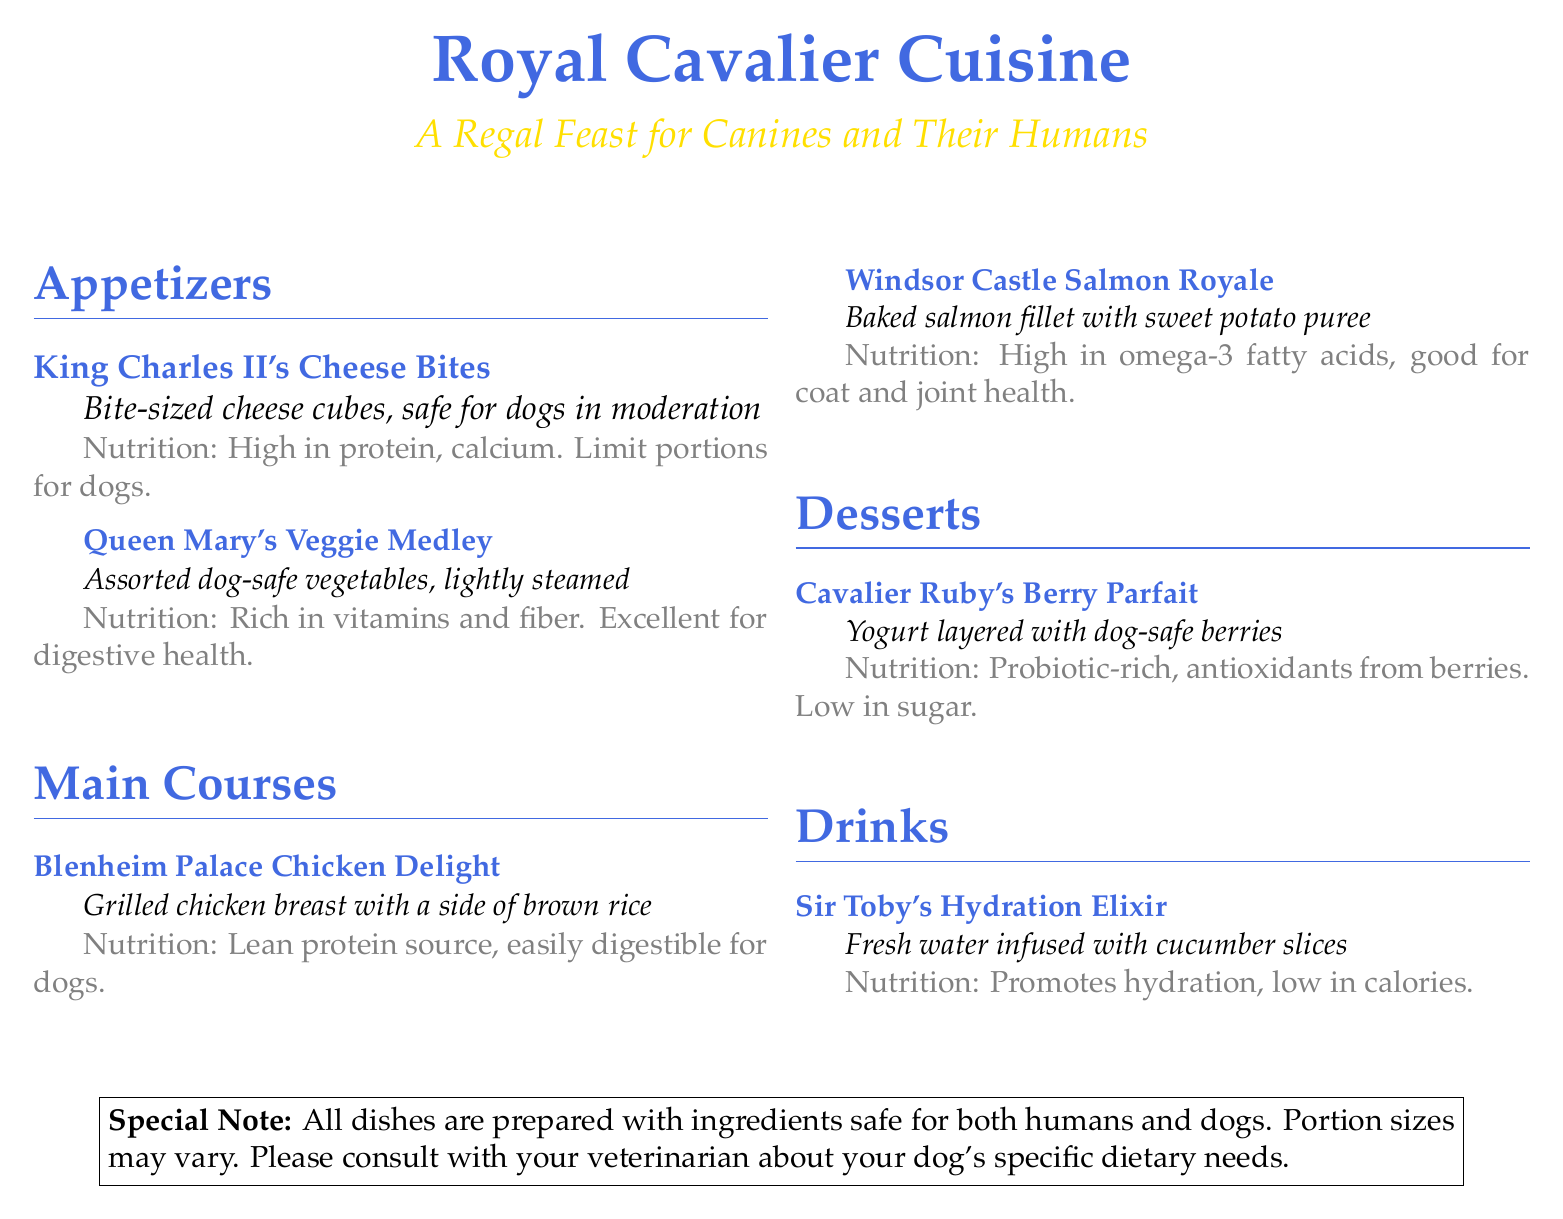What is the name of the cheese appetizer? The cheese appetizer is called "King Charles II's Cheese Bites."
Answer: King Charles II's Cheese Bites How many main courses are listed on the menu? There are two main courses listed on the menu: "Blenheim Palace Chicken Delight" and "Windsor Castle Salmon Royale."
Answer: 2 What vegetable dish is on the appetizer menu? The vegetable dish on the appetizer menu is "Queen Mary's Veggie Medley."
Answer: Queen Mary's Veggie Medley What is a key nutritional benefit of the salmon dish? The "Windsor Castle Salmon Royale" is high in omega-3 fatty acids, which are good for coat and joint health.
Answer: Omega-3 fatty acids Which drink is associated with Sir Toby? The drink associated with Sir Toby is "Sir Toby's Hydration Elixir."
Answer: Sir Toby's Hydration Elixir What is the primary dessert ingredient used in the parfait? The primary dessert ingredient used in the parfait is yogurt, layered with dog-safe berries.
Answer: Yogurt Is there a special note regarding food safety? Yes, there is a special note stating that all dishes are prepared with ingredients safe for both humans and dogs.
Answer: Yes What type of cuisine is the menu representing? The menu is representing royal-themed cuisine.
Answer: Royal-themed cuisine What safety advice is given for portion sizes? The menu advises consulting with a veterinarian about a dog's specific dietary needs regarding portion sizes.
Answer: Consult with your veterinarian 